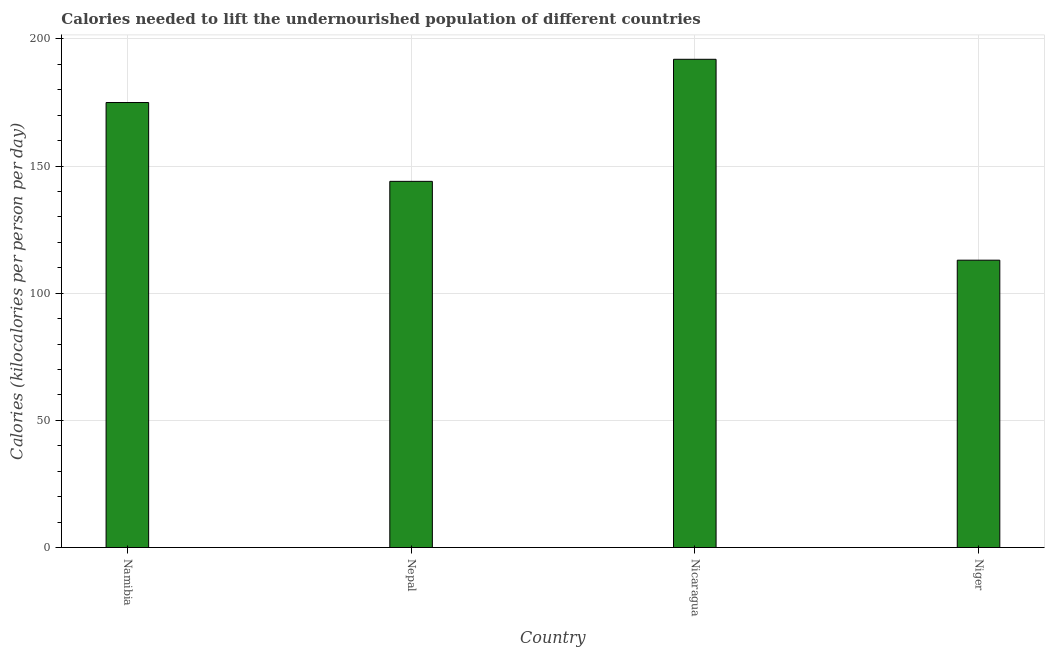What is the title of the graph?
Make the answer very short. Calories needed to lift the undernourished population of different countries. What is the label or title of the X-axis?
Ensure brevity in your answer.  Country. What is the label or title of the Y-axis?
Give a very brief answer. Calories (kilocalories per person per day). What is the depth of food deficit in Niger?
Your answer should be compact. 113. Across all countries, what is the maximum depth of food deficit?
Provide a short and direct response. 192. Across all countries, what is the minimum depth of food deficit?
Your answer should be compact. 113. In which country was the depth of food deficit maximum?
Provide a succinct answer. Nicaragua. In which country was the depth of food deficit minimum?
Your answer should be compact. Niger. What is the sum of the depth of food deficit?
Your answer should be very brief. 624. What is the difference between the depth of food deficit in Nepal and Nicaragua?
Provide a short and direct response. -48. What is the average depth of food deficit per country?
Your response must be concise. 156. What is the median depth of food deficit?
Make the answer very short. 159.5. In how many countries, is the depth of food deficit greater than 90 kilocalories?
Your answer should be compact. 4. What is the ratio of the depth of food deficit in Namibia to that in Nepal?
Ensure brevity in your answer.  1.22. Is the difference between the depth of food deficit in Nicaragua and Niger greater than the difference between any two countries?
Offer a very short reply. Yes. Is the sum of the depth of food deficit in Nepal and Niger greater than the maximum depth of food deficit across all countries?
Give a very brief answer. Yes. What is the difference between the highest and the lowest depth of food deficit?
Provide a short and direct response. 79. In how many countries, is the depth of food deficit greater than the average depth of food deficit taken over all countries?
Provide a succinct answer. 2. Are all the bars in the graph horizontal?
Keep it short and to the point. No. How many countries are there in the graph?
Your answer should be compact. 4. What is the difference between two consecutive major ticks on the Y-axis?
Offer a terse response. 50. What is the Calories (kilocalories per person per day) of Namibia?
Offer a very short reply. 175. What is the Calories (kilocalories per person per day) in Nepal?
Your answer should be very brief. 144. What is the Calories (kilocalories per person per day) of Nicaragua?
Ensure brevity in your answer.  192. What is the Calories (kilocalories per person per day) of Niger?
Your response must be concise. 113. What is the difference between the Calories (kilocalories per person per day) in Namibia and Nepal?
Provide a short and direct response. 31. What is the difference between the Calories (kilocalories per person per day) in Namibia and Niger?
Provide a short and direct response. 62. What is the difference between the Calories (kilocalories per person per day) in Nepal and Nicaragua?
Make the answer very short. -48. What is the difference between the Calories (kilocalories per person per day) in Nepal and Niger?
Keep it short and to the point. 31. What is the difference between the Calories (kilocalories per person per day) in Nicaragua and Niger?
Offer a very short reply. 79. What is the ratio of the Calories (kilocalories per person per day) in Namibia to that in Nepal?
Give a very brief answer. 1.22. What is the ratio of the Calories (kilocalories per person per day) in Namibia to that in Nicaragua?
Make the answer very short. 0.91. What is the ratio of the Calories (kilocalories per person per day) in Namibia to that in Niger?
Offer a terse response. 1.55. What is the ratio of the Calories (kilocalories per person per day) in Nepal to that in Niger?
Offer a very short reply. 1.27. What is the ratio of the Calories (kilocalories per person per day) in Nicaragua to that in Niger?
Your answer should be compact. 1.7. 